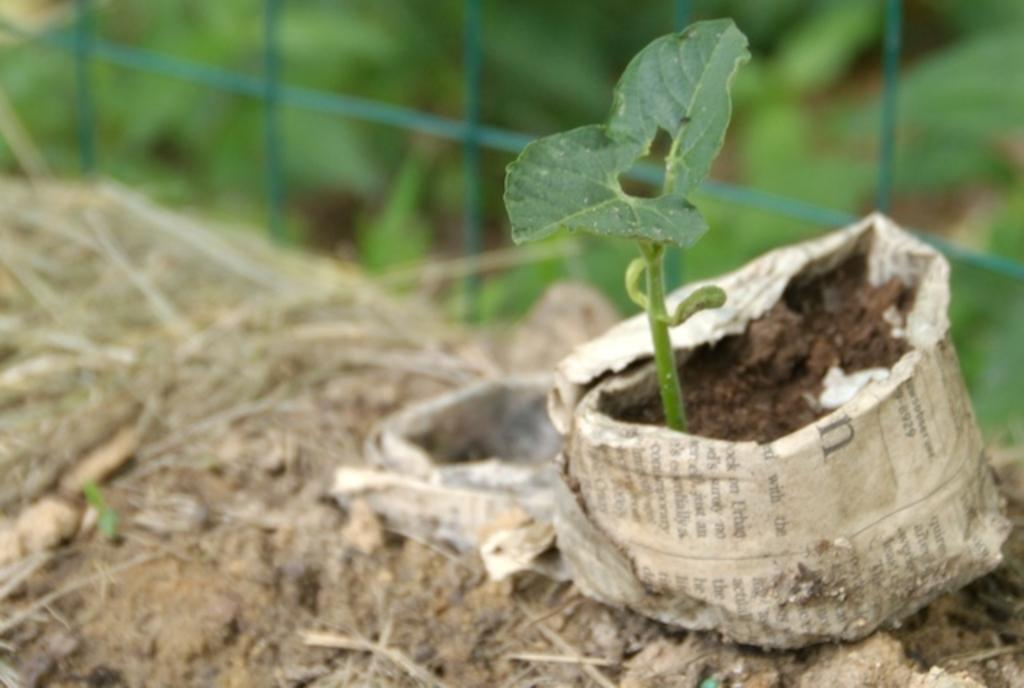What is present in the image? There is a plant in the image. How is the plant situated? The plant is planted in the mud. What can be seen on the ground in the image? The ground is visible in the image. What type of plants are visible in the background? There are green color plants in the background of the image. What else can be seen in the background? There is a mesh in the background of the image. What type of carriage can be seen in the image? There is no carriage present in the image. Is there a kite flying in the background of the image? There is no kite visible in the image. 